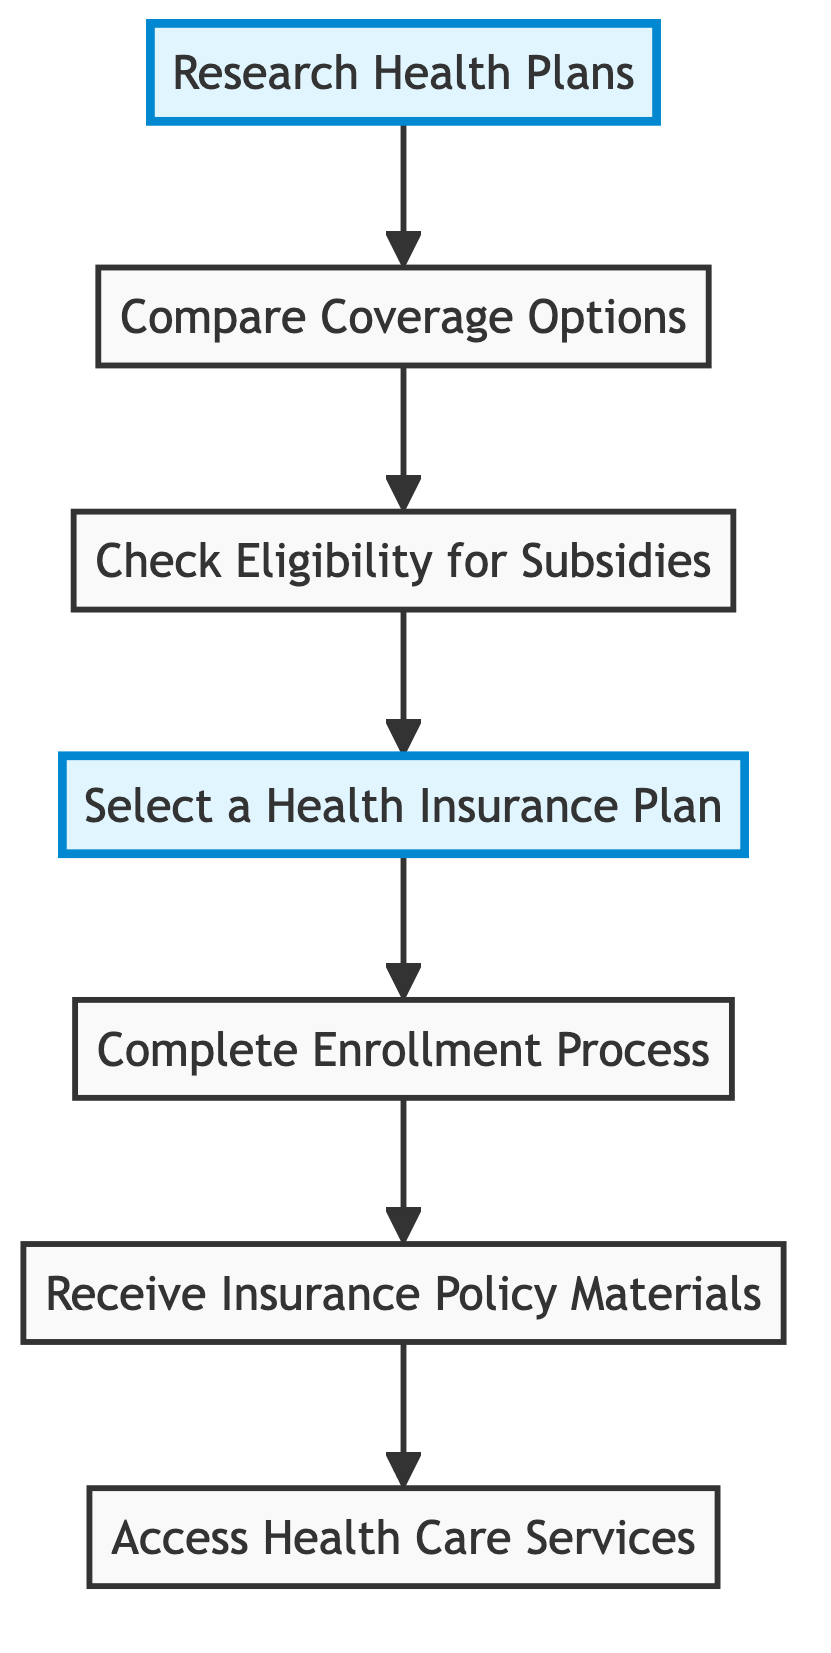What is the first step in the enrollment process? The first step in the diagram is "Research Health Plans," which is the initial node in the directed graph.
Answer: Research Health Plans How many steps are there before accessing benefits? To access benefits, one must go through six distinct steps: Research Health Plans, Compare Coverage Options, Check Eligibility for Subsidies, Select a Health Insurance Plan, Complete Enrollment Process, and Receive Insurance Policy Materials.
Answer: 6 What is the relationship between "Select a Health Insurance Plan" and "Complete Enrollment Process"? The directed edge indicates that "Select a Health Insurance Plan" directly leads to "Complete Enrollment Process," suggesting that selecting a plan is a prerequisite for completing enrollment.
Answer: Directly leads to Which step follows "Receive Insurance Policy Materials"? The step that follows "Receive Insurance Policy Materials" is "Access Health Care Services," according to the flow of the directed graph.
Answer: Access Health Care Services How many edges are in the diagram? The diagram contains six edges, which represent the connections between the seven nodes in the enrollment process.
Answer: 6 What can be inferred if a person skips "Check Eligibility for Subsidies"? Skipping "Check Eligibility for Subsidies" means that the individual would not move to the next step, "Select a Health Insurance Plan," potentially missing available subsidies. This indicates that skipping this step can prevent access to subsidies.
Answer: Potentially missing subsidies Which nodes are highlighted in the graph? The nodes highlighted in the graph are "Research Health Plans" and "Select a Health Insurance Plan," indicating their significance in the enrollment process.
Answer: Research Health Plans and Select a Health Insurance Plan What is the last step of the process? The last step in the diagram is "Access Health Care Services," which concludes the enrollment process and the flow depicted in the directed graph.
Answer: Access Health Care Services 